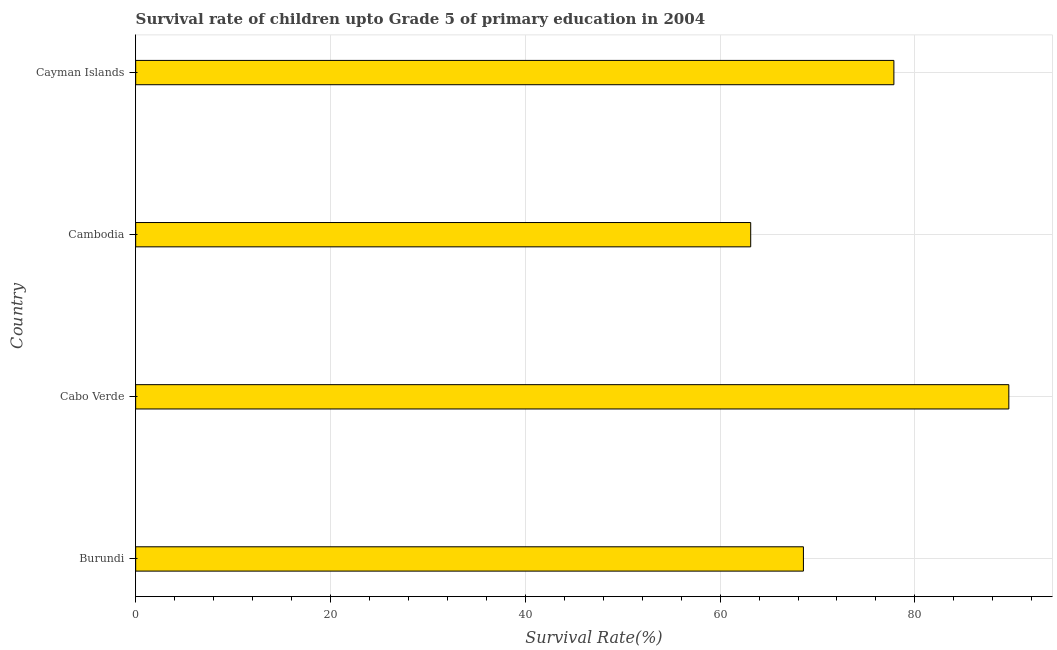Does the graph contain any zero values?
Ensure brevity in your answer.  No. Does the graph contain grids?
Give a very brief answer. Yes. What is the title of the graph?
Offer a terse response. Survival rate of children upto Grade 5 of primary education in 2004 . What is the label or title of the X-axis?
Keep it short and to the point. Survival Rate(%). What is the label or title of the Y-axis?
Give a very brief answer. Country. What is the survival rate in Cambodia?
Provide a succinct answer. 63.14. Across all countries, what is the maximum survival rate?
Your answer should be very brief. 89.64. Across all countries, what is the minimum survival rate?
Offer a terse response. 63.14. In which country was the survival rate maximum?
Make the answer very short. Cabo Verde. In which country was the survival rate minimum?
Your answer should be very brief. Cambodia. What is the sum of the survival rate?
Offer a terse response. 299.18. What is the average survival rate per country?
Give a very brief answer. 74.8. What is the median survival rate?
Your response must be concise. 73.2. In how many countries, is the survival rate greater than 44 %?
Give a very brief answer. 4. What is the ratio of the survival rate in Burundi to that in Cabo Verde?
Your answer should be compact. 0.77. What is the difference between the highest and the second highest survival rate?
Keep it short and to the point. 11.8. Is the sum of the survival rate in Burundi and Cambodia greater than the maximum survival rate across all countries?
Your answer should be compact. Yes. What is the difference between the highest and the lowest survival rate?
Provide a succinct answer. 26.5. How many bars are there?
Your answer should be compact. 4. Are all the bars in the graph horizontal?
Give a very brief answer. Yes. How many countries are there in the graph?
Keep it short and to the point. 4. Are the values on the major ticks of X-axis written in scientific E-notation?
Give a very brief answer. No. What is the Survival Rate(%) in Burundi?
Provide a short and direct response. 68.55. What is the Survival Rate(%) of Cabo Verde?
Give a very brief answer. 89.64. What is the Survival Rate(%) of Cambodia?
Offer a very short reply. 63.14. What is the Survival Rate(%) of Cayman Islands?
Offer a terse response. 77.84. What is the difference between the Survival Rate(%) in Burundi and Cabo Verde?
Keep it short and to the point. -21.09. What is the difference between the Survival Rate(%) in Burundi and Cambodia?
Give a very brief answer. 5.41. What is the difference between the Survival Rate(%) in Burundi and Cayman Islands?
Your answer should be very brief. -9.29. What is the difference between the Survival Rate(%) in Cabo Verde and Cambodia?
Provide a succinct answer. 26.5. What is the difference between the Survival Rate(%) in Cabo Verde and Cayman Islands?
Provide a succinct answer. 11.8. What is the difference between the Survival Rate(%) in Cambodia and Cayman Islands?
Ensure brevity in your answer.  -14.7. What is the ratio of the Survival Rate(%) in Burundi to that in Cabo Verde?
Make the answer very short. 0.77. What is the ratio of the Survival Rate(%) in Burundi to that in Cambodia?
Your response must be concise. 1.09. What is the ratio of the Survival Rate(%) in Burundi to that in Cayman Islands?
Your answer should be very brief. 0.88. What is the ratio of the Survival Rate(%) in Cabo Verde to that in Cambodia?
Your response must be concise. 1.42. What is the ratio of the Survival Rate(%) in Cabo Verde to that in Cayman Islands?
Ensure brevity in your answer.  1.15. What is the ratio of the Survival Rate(%) in Cambodia to that in Cayman Islands?
Your answer should be compact. 0.81. 